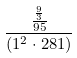Convert formula to latex. <formula><loc_0><loc_0><loc_500><loc_500>\frac { \frac { \frac { 9 } { 3 } } { 9 5 } } { ( 1 ^ { 2 } \cdot 2 8 1 ) }</formula> 